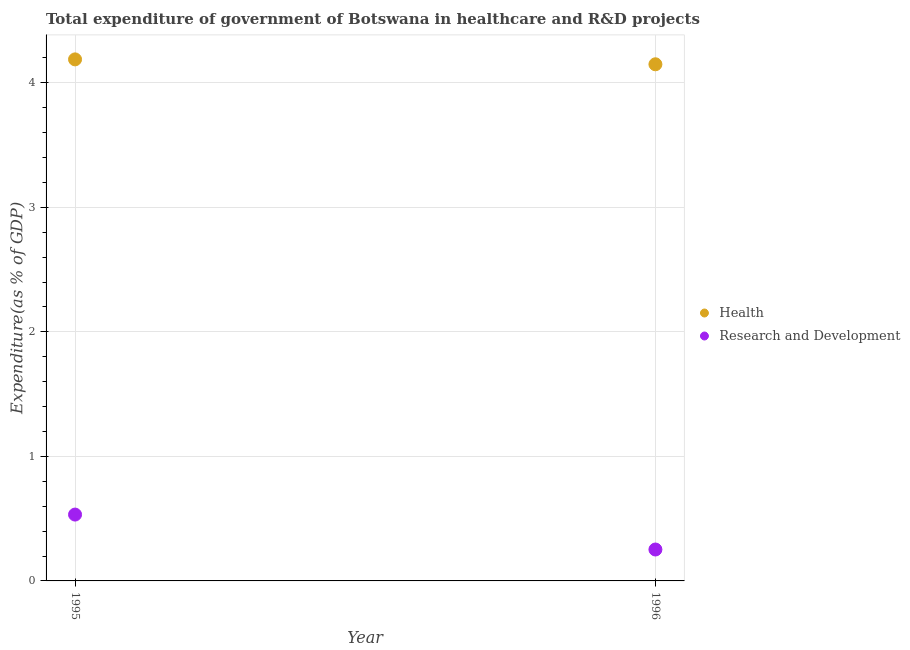How many different coloured dotlines are there?
Ensure brevity in your answer.  2. What is the expenditure in healthcare in 1995?
Provide a short and direct response. 4.19. Across all years, what is the maximum expenditure in r&d?
Provide a succinct answer. 0.53. Across all years, what is the minimum expenditure in r&d?
Offer a very short reply. 0.25. What is the total expenditure in healthcare in the graph?
Offer a terse response. 8.34. What is the difference between the expenditure in r&d in 1995 and that in 1996?
Keep it short and to the point. 0.28. What is the difference between the expenditure in r&d in 1996 and the expenditure in healthcare in 1995?
Keep it short and to the point. -3.94. What is the average expenditure in r&d per year?
Offer a very short reply. 0.39. In the year 1995, what is the difference between the expenditure in r&d and expenditure in healthcare?
Offer a very short reply. -3.66. In how many years, is the expenditure in healthcare greater than 0.6000000000000001 %?
Offer a very short reply. 2. What is the ratio of the expenditure in r&d in 1995 to that in 1996?
Your answer should be very brief. 2.11. Is the expenditure in healthcare in 1995 less than that in 1996?
Offer a very short reply. No. In how many years, is the expenditure in r&d greater than the average expenditure in r&d taken over all years?
Your answer should be very brief. 1. Does the expenditure in healthcare monotonically increase over the years?
Offer a terse response. No. Is the expenditure in r&d strictly greater than the expenditure in healthcare over the years?
Ensure brevity in your answer.  No. How many dotlines are there?
Keep it short and to the point. 2. How many years are there in the graph?
Your answer should be compact. 2. Are the values on the major ticks of Y-axis written in scientific E-notation?
Ensure brevity in your answer.  No. Does the graph contain any zero values?
Your answer should be very brief. No. How many legend labels are there?
Provide a short and direct response. 2. How are the legend labels stacked?
Provide a succinct answer. Vertical. What is the title of the graph?
Offer a very short reply. Total expenditure of government of Botswana in healthcare and R&D projects. What is the label or title of the Y-axis?
Your answer should be very brief. Expenditure(as % of GDP). What is the Expenditure(as % of GDP) of Health in 1995?
Offer a terse response. 4.19. What is the Expenditure(as % of GDP) of Research and Development in 1995?
Your response must be concise. 0.53. What is the Expenditure(as % of GDP) of Health in 1996?
Ensure brevity in your answer.  4.15. What is the Expenditure(as % of GDP) in Research and Development in 1996?
Your answer should be compact. 0.25. Across all years, what is the maximum Expenditure(as % of GDP) of Health?
Make the answer very short. 4.19. Across all years, what is the maximum Expenditure(as % of GDP) of Research and Development?
Offer a terse response. 0.53. Across all years, what is the minimum Expenditure(as % of GDP) in Health?
Your answer should be very brief. 4.15. Across all years, what is the minimum Expenditure(as % of GDP) of Research and Development?
Your answer should be very brief. 0.25. What is the total Expenditure(as % of GDP) of Health in the graph?
Offer a terse response. 8.34. What is the total Expenditure(as % of GDP) of Research and Development in the graph?
Provide a short and direct response. 0.79. What is the difference between the Expenditure(as % of GDP) of Health in 1995 and that in 1996?
Provide a short and direct response. 0.04. What is the difference between the Expenditure(as % of GDP) of Research and Development in 1995 and that in 1996?
Your answer should be compact. 0.28. What is the difference between the Expenditure(as % of GDP) in Health in 1995 and the Expenditure(as % of GDP) in Research and Development in 1996?
Provide a short and direct response. 3.94. What is the average Expenditure(as % of GDP) of Health per year?
Keep it short and to the point. 4.17. What is the average Expenditure(as % of GDP) of Research and Development per year?
Offer a very short reply. 0.39. In the year 1995, what is the difference between the Expenditure(as % of GDP) of Health and Expenditure(as % of GDP) of Research and Development?
Offer a very short reply. 3.66. In the year 1996, what is the difference between the Expenditure(as % of GDP) of Health and Expenditure(as % of GDP) of Research and Development?
Your response must be concise. 3.9. What is the ratio of the Expenditure(as % of GDP) of Health in 1995 to that in 1996?
Provide a succinct answer. 1.01. What is the ratio of the Expenditure(as % of GDP) of Research and Development in 1995 to that in 1996?
Offer a terse response. 2.11. What is the difference between the highest and the second highest Expenditure(as % of GDP) in Health?
Ensure brevity in your answer.  0.04. What is the difference between the highest and the second highest Expenditure(as % of GDP) of Research and Development?
Offer a terse response. 0.28. What is the difference between the highest and the lowest Expenditure(as % of GDP) in Health?
Offer a terse response. 0.04. What is the difference between the highest and the lowest Expenditure(as % of GDP) in Research and Development?
Make the answer very short. 0.28. 